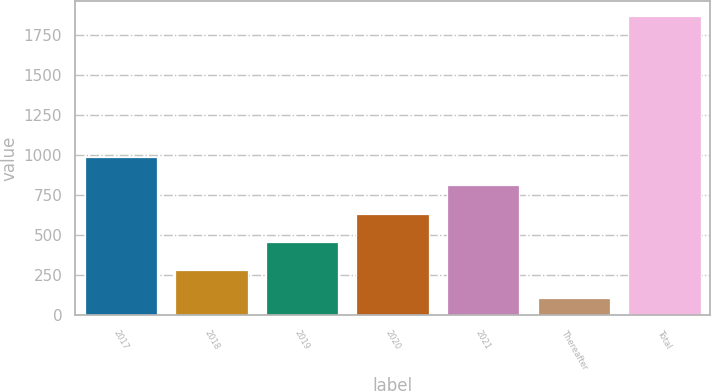<chart> <loc_0><loc_0><loc_500><loc_500><bar_chart><fcel>2017<fcel>2018<fcel>2019<fcel>2020<fcel>2021<fcel>Thereafter<fcel>Total<nl><fcel>988.5<fcel>282.5<fcel>459<fcel>635.5<fcel>812<fcel>106<fcel>1871<nl></chart> 